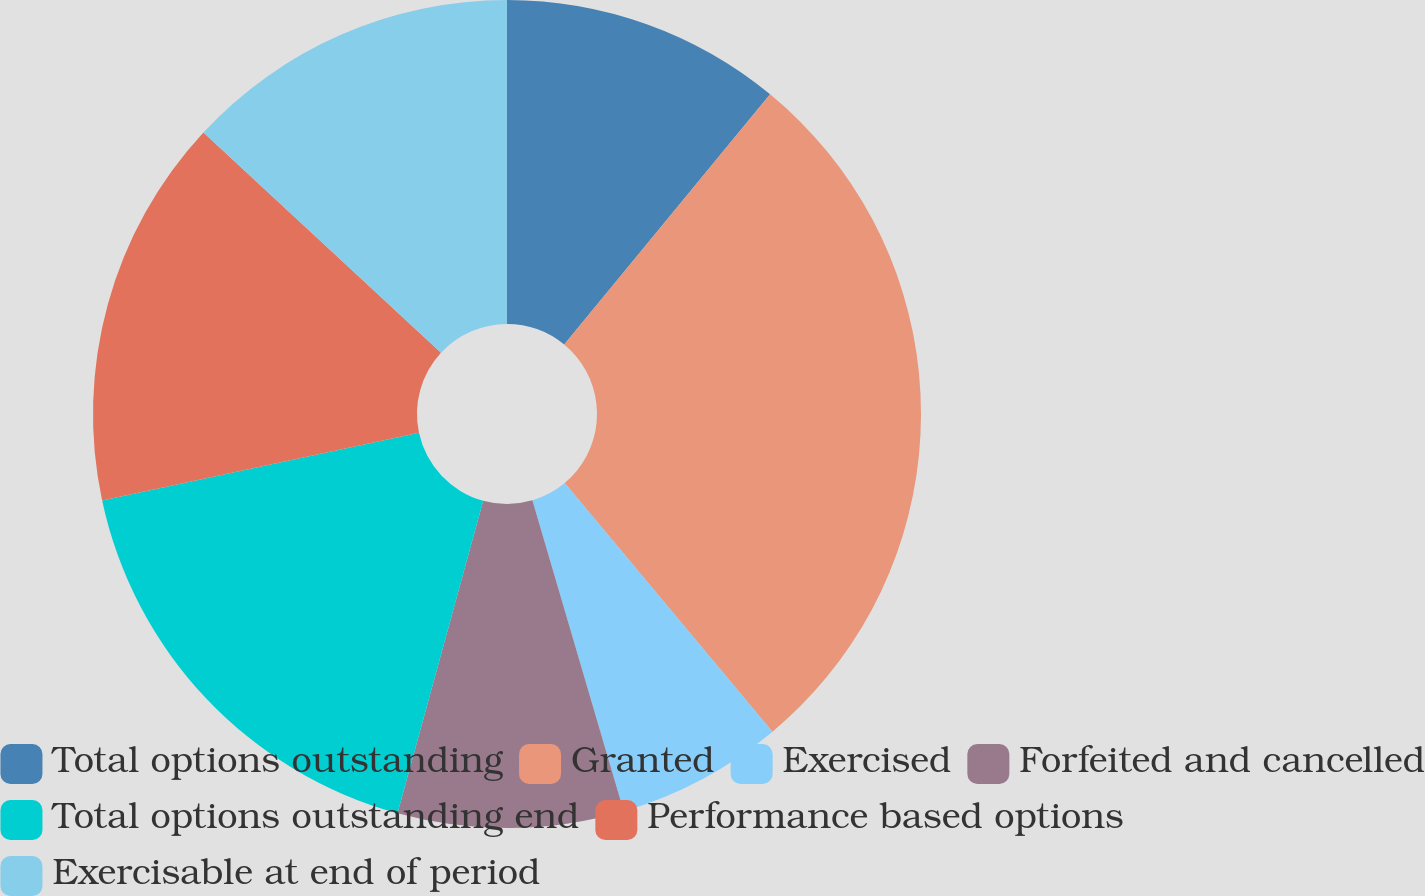Convert chart. <chart><loc_0><loc_0><loc_500><loc_500><pie_chart><fcel>Total options outstanding<fcel>Granted<fcel>Exercised<fcel>Forfeited and cancelled<fcel>Total options outstanding end<fcel>Performance based options<fcel>Exercisable at end of period<nl><fcel>10.96%<fcel>27.96%<fcel>6.53%<fcel>8.81%<fcel>17.39%<fcel>15.25%<fcel>13.1%<nl></chart> 